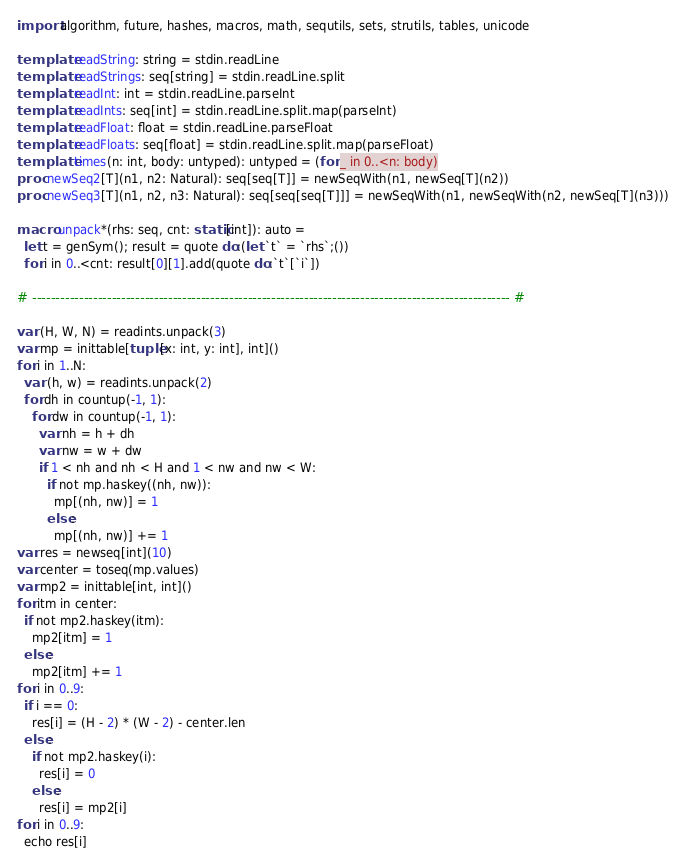Convert code to text. <code><loc_0><loc_0><loc_500><loc_500><_Nim_>import algorithm, future, hashes, macros, math, sequtils, sets, strutils, tables, unicode

template readString: string = stdin.readLine
template readStrings: seq[string] = stdin.readLine.split
template readInt: int = stdin.readLine.parseInt
template readInts: seq[int] = stdin.readLine.split.map(parseInt)
template readFloat: float = stdin.readLine.parseFloat
template readFloats: seq[float] = stdin.readLine.split.map(parseFloat)
template times(n: int, body: untyped): untyped = (for _ in 0..<n: body)
proc newSeq2[T](n1, n2: Natural): seq[seq[T]] = newSeqWith(n1, newSeq[T](n2))
proc newSeq3[T](n1, n2, n3: Natural): seq[seq[seq[T]]] = newSeqWith(n1, newSeqWith(n2, newSeq[T](n3)))

macro unpack*(rhs: seq, cnt: static[int]): auto =
  let t = genSym(); result = quote do:(let `t` = `rhs`;())
  for i in 0..<cnt: result[0][1].add(quote do:`t`[`i`])

# ------------------------------------------------------------------------------------------------------ #

var (H, W, N) = readints.unpack(3)
var mp = inittable[tuple[x: int, y: int], int]()
for i in 1..N:
  var (h, w) = readints.unpack(2)
  for dh in countup(-1, 1):
    for dw in countup(-1, 1):
      var nh = h + dh
      var nw = w + dw
      if 1 < nh and nh < H and 1 < nw and nw < W:
        if not mp.haskey((nh, nw)):
          mp[(nh, nw)] = 1
        else:
          mp[(nh, nw)] += 1
var res = newseq[int](10)
var center = toseq(mp.values)
var mp2 = inittable[int, int]()
for itm in center:
  if not mp2.haskey(itm):
    mp2[itm] = 1
  else:
    mp2[itm] += 1
for i in 0..9:
  if i == 0:
    res[i] = (H - 2) * (W - 2) - center.len
  else:
    if not mp2.haskey(i):
      res[i] = 0
    else:
      res[i] = mp2[i]
for i in 0..9:
  echo res[i]</code> 